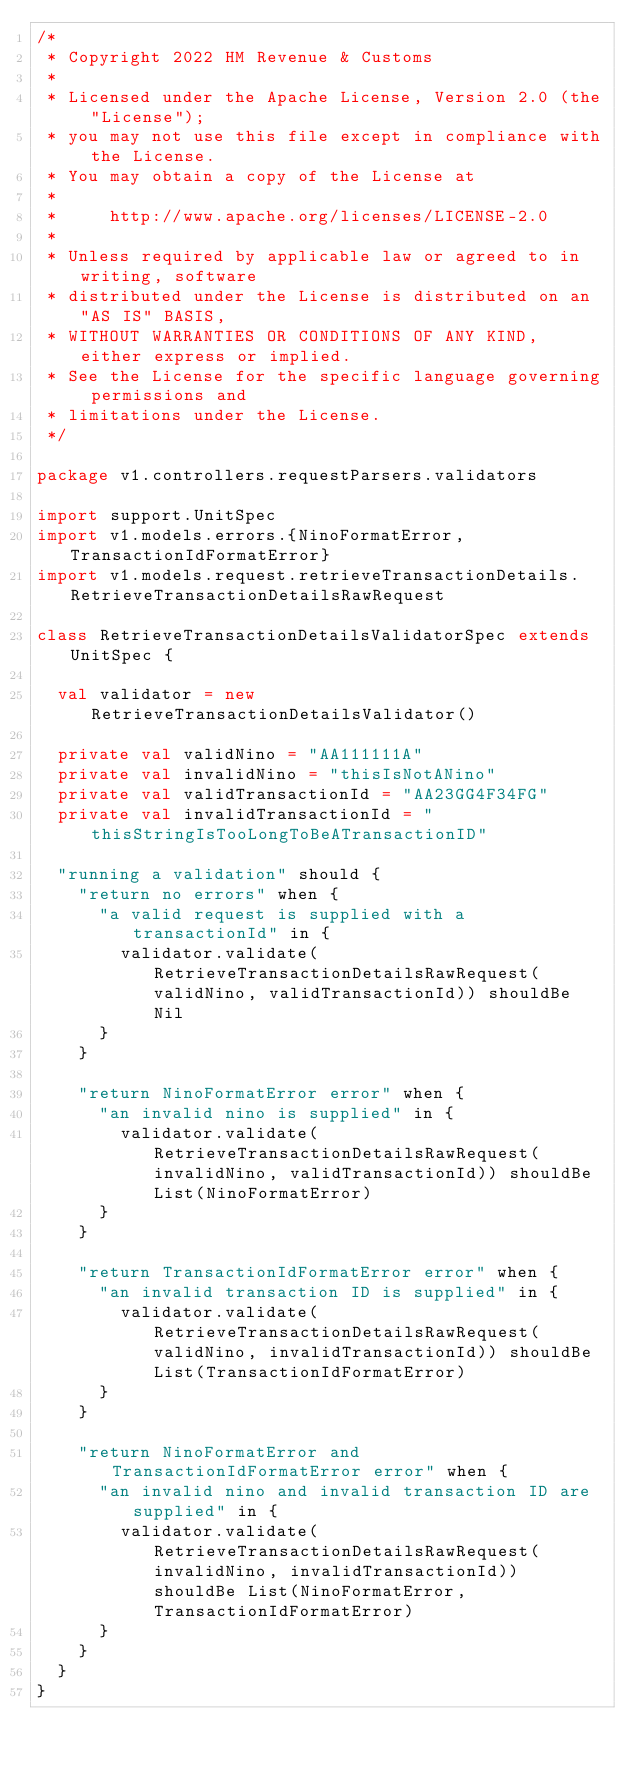Convert code to text. <code><loc_0><loc_0><loc_500><loc_500><_Scala_>/*
 * Copyright 2022 HM Revenue & Customs
 *
 * Licensed under the Apache License, Version 2.0 (the "License");
 * you may not use this file except in compliance with the License.
 * You may obtain a copy of the License at
 *
 *     http://www.apache.org/licenses/LICENSE-2.0
 *
 * Unless required by applicable law or agreed to in writing, software
 * distributed under the License is distributed on an "AS IS" BASIS,
 * WITHOUT WARRANTIES OR CONDITIONS OF ANY KIND, either express or implied.
 * See the License for the specific language governing permissions and
 * limitations under the License.
 */

package v1.controllers.requestParsers.validators

import support.UnitSpec
import v1.models.errors.{NinoFormatError, TransactionIdFormatError}
import v1.models.request.retrieveTransactionDetails.RetrieveTransactionDetailsRawRequest

class RetrieveTransactionDetailsValidatorSpec extends UnitSpec {

  val validator = new RetrieveTransactionDetailsValidator()

  private val validNino = "AA111111A"
  private val invalidNino = "thisIsNotANino"
  private val validTransactionId = "AA23GG4F34FG"
  private val invalidTransactionId = "thisStringIsTooLongToBeATransactionID"

  "running a validation" should {
    "return no errors" when {
      "a valid request is supplied with a transactionId" in {
        validator.validate(RetrieveTransactionDetailsRawRequest(validNino, validTransactionId)) shouldBe Nil
      }
    }

    "return NinoFormatError error" when {
      "an invalid nino is supplied" in {
        validator.validate(RetrieveTransactionDetailsRawRequest(invalidNino, validTransactionId)) shouldBe List(NinoFormatError)
      }
    }

    "return TransactionIdFormatError error" when {
      "an invalid transaction ID is supplied" in {
        validator.validate(RetrieveTransactionDetailsRawRequest(validNino, invalidTransactionId)) shouldBe List(TransactionIdFormatError)
      }
    }

    "return NinoFormatError and TransactionIdFormatError error" when {
      "an invalid nino and invalid transaction ID are supplied" in {
        validator.validate(RetrieveTransactionDetailsRawRequest(invalidNino, invalidTransactionId)) shouldBe List(NinoFormatError, TransactionIdFormatError)
      }
    }
  }
}
</code> 